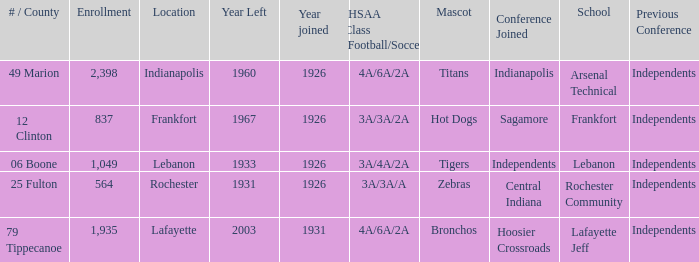What is the lowest enrollment that has Lafayette as the location? 1935.0. 